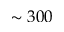<formula> <loc_0><loc_0><loc_500><loc_500>\sim 3 0 0</formula> 